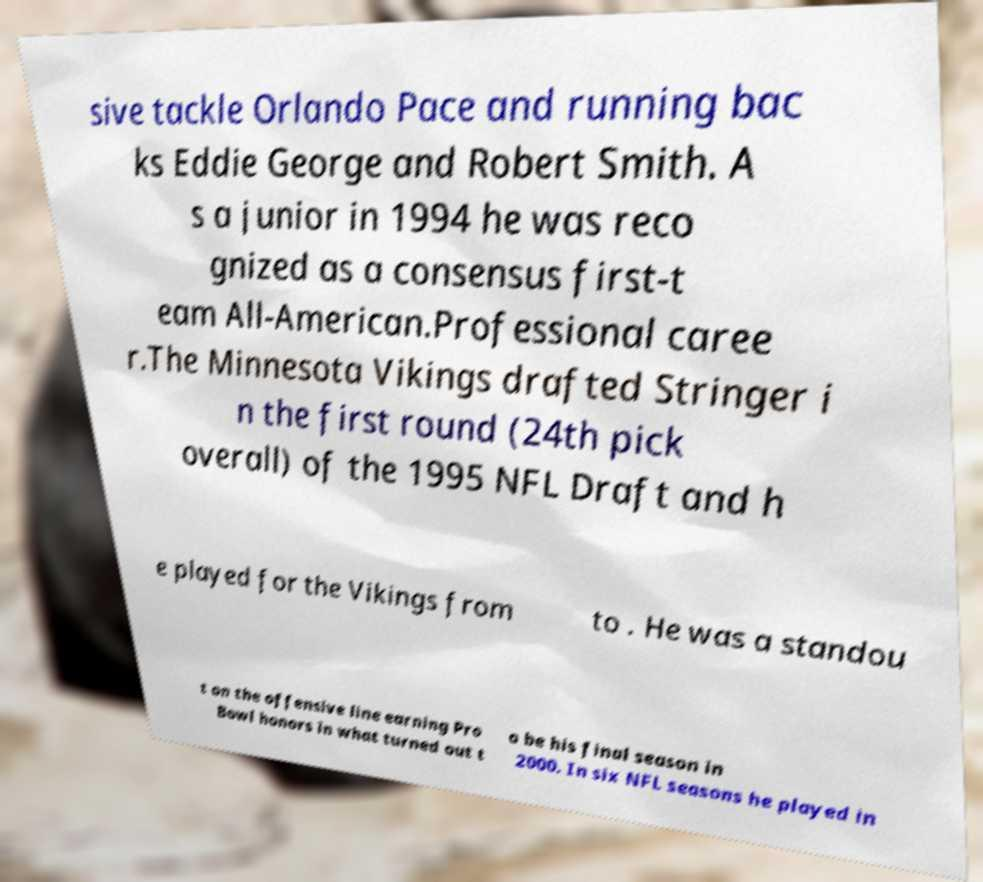Could you extract and type out the text from this image? sive tackle Orlando Pace and running bac ks Eddie George and Robert Smith. A s a junior in 1994 he was reco gnized as a consensus first-t eam All-American.Professional caree r.The Minnesota Vikings drafted Stringer i n the first round (24th pick overall) of the 1995 NFL Draft and h e played for the Vikings from to . He was a standou t on the offensive line earning Pro Bowl honors in what turned out t o be his final season in 2000. In six NFL seasons he played in 